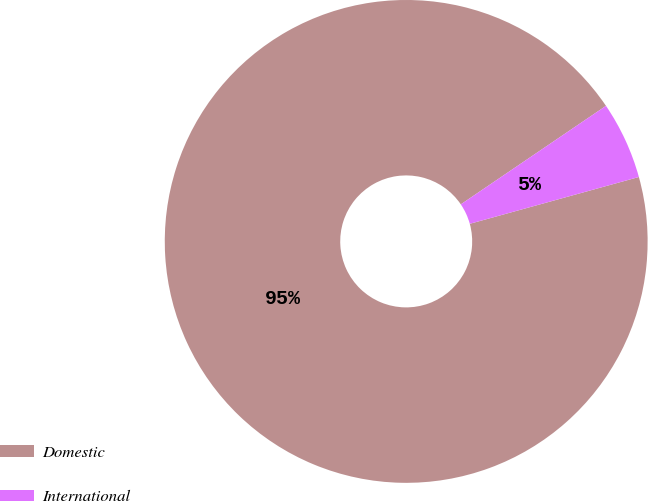Convert chart. <chart><loc_0><loc_0><loc_500><loc_500><pie_chart><fcel>Domestic<fcel>International<nl><fcel>94.81%<fcel>5.19%<nl></chart> 